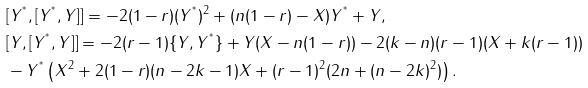Convert formula to latex. <formula><loc_0><loc_0><loc_500><loc_500>& [ Y ^ { ^ { * } } , [ Y ^ { ^ { * } } , Y ] ] = - 2 ( 1 - r ) ( Y ^ { ^ { * } } ) ^ { 2 } + ( n ( 1 - r ) - X ) Y ^ { ^ { * } } + Y , \\ & [ Y , [ Y ^ { ^ { * } } , Y ] ] = - 2 ( r - 1 ) \{ Y , Y ^ { ^ { * } } \} + Y ( X - n ( 1 - r ) ) - 2 ( k - n ) ( r - 1 ) ( X + k ( r - 1 ) ) \\ & - Y ^ { ^ { * } } \left ( X ^ { 2 } + 2 ( 1 - r ) ( n - 2 k - 1 ) X + ( r - 1 ) ^ { 2 } ( 2 n + ( n - 2 k ) ^ { 2 } ) \right ) .</formula> 